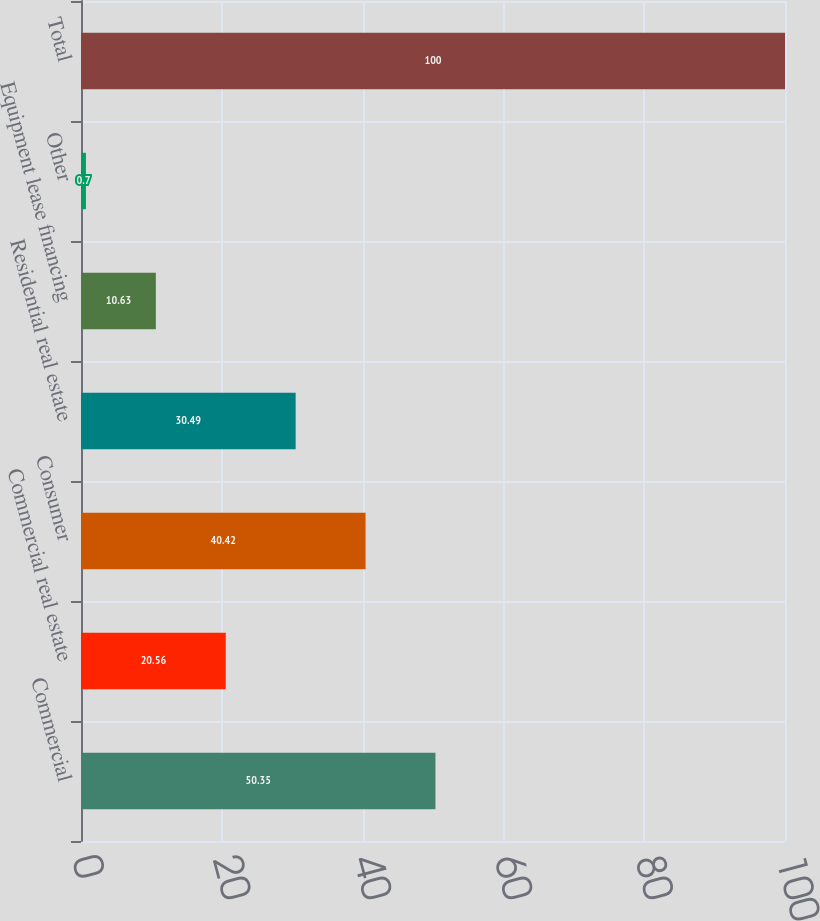Convert chart to OTSL. <chart><loc_0><loc_0><loc_500><loc_500><bar_chart><fcel>Commercial<fcel>Commercial real estate<fcel>Consumer<fcel>Residential real estate<fcel>Equipment lease financing<fcel>Other<fcel>Total<nl><fcel>50.35<fcel>20.56<fcel>40.42<fcel>30.49<fcel>10.63<fcel>0.7<fcel>100<nl></chart> 